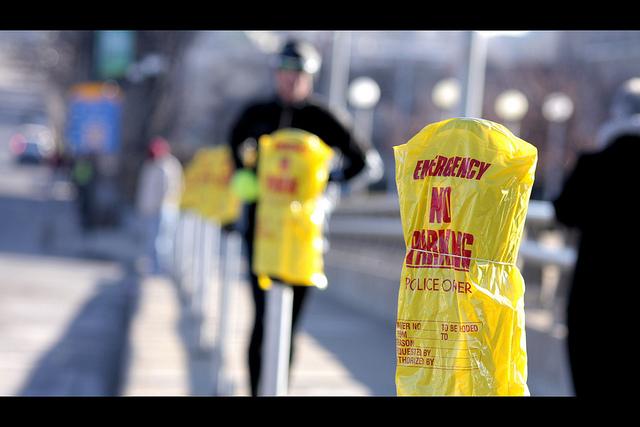Who is the man in the photo?
Answer briefly. Police. What color is the cover?
Give a very brief answer. Yellow. Can these parking meters be used?
Write a very short answer. No. 